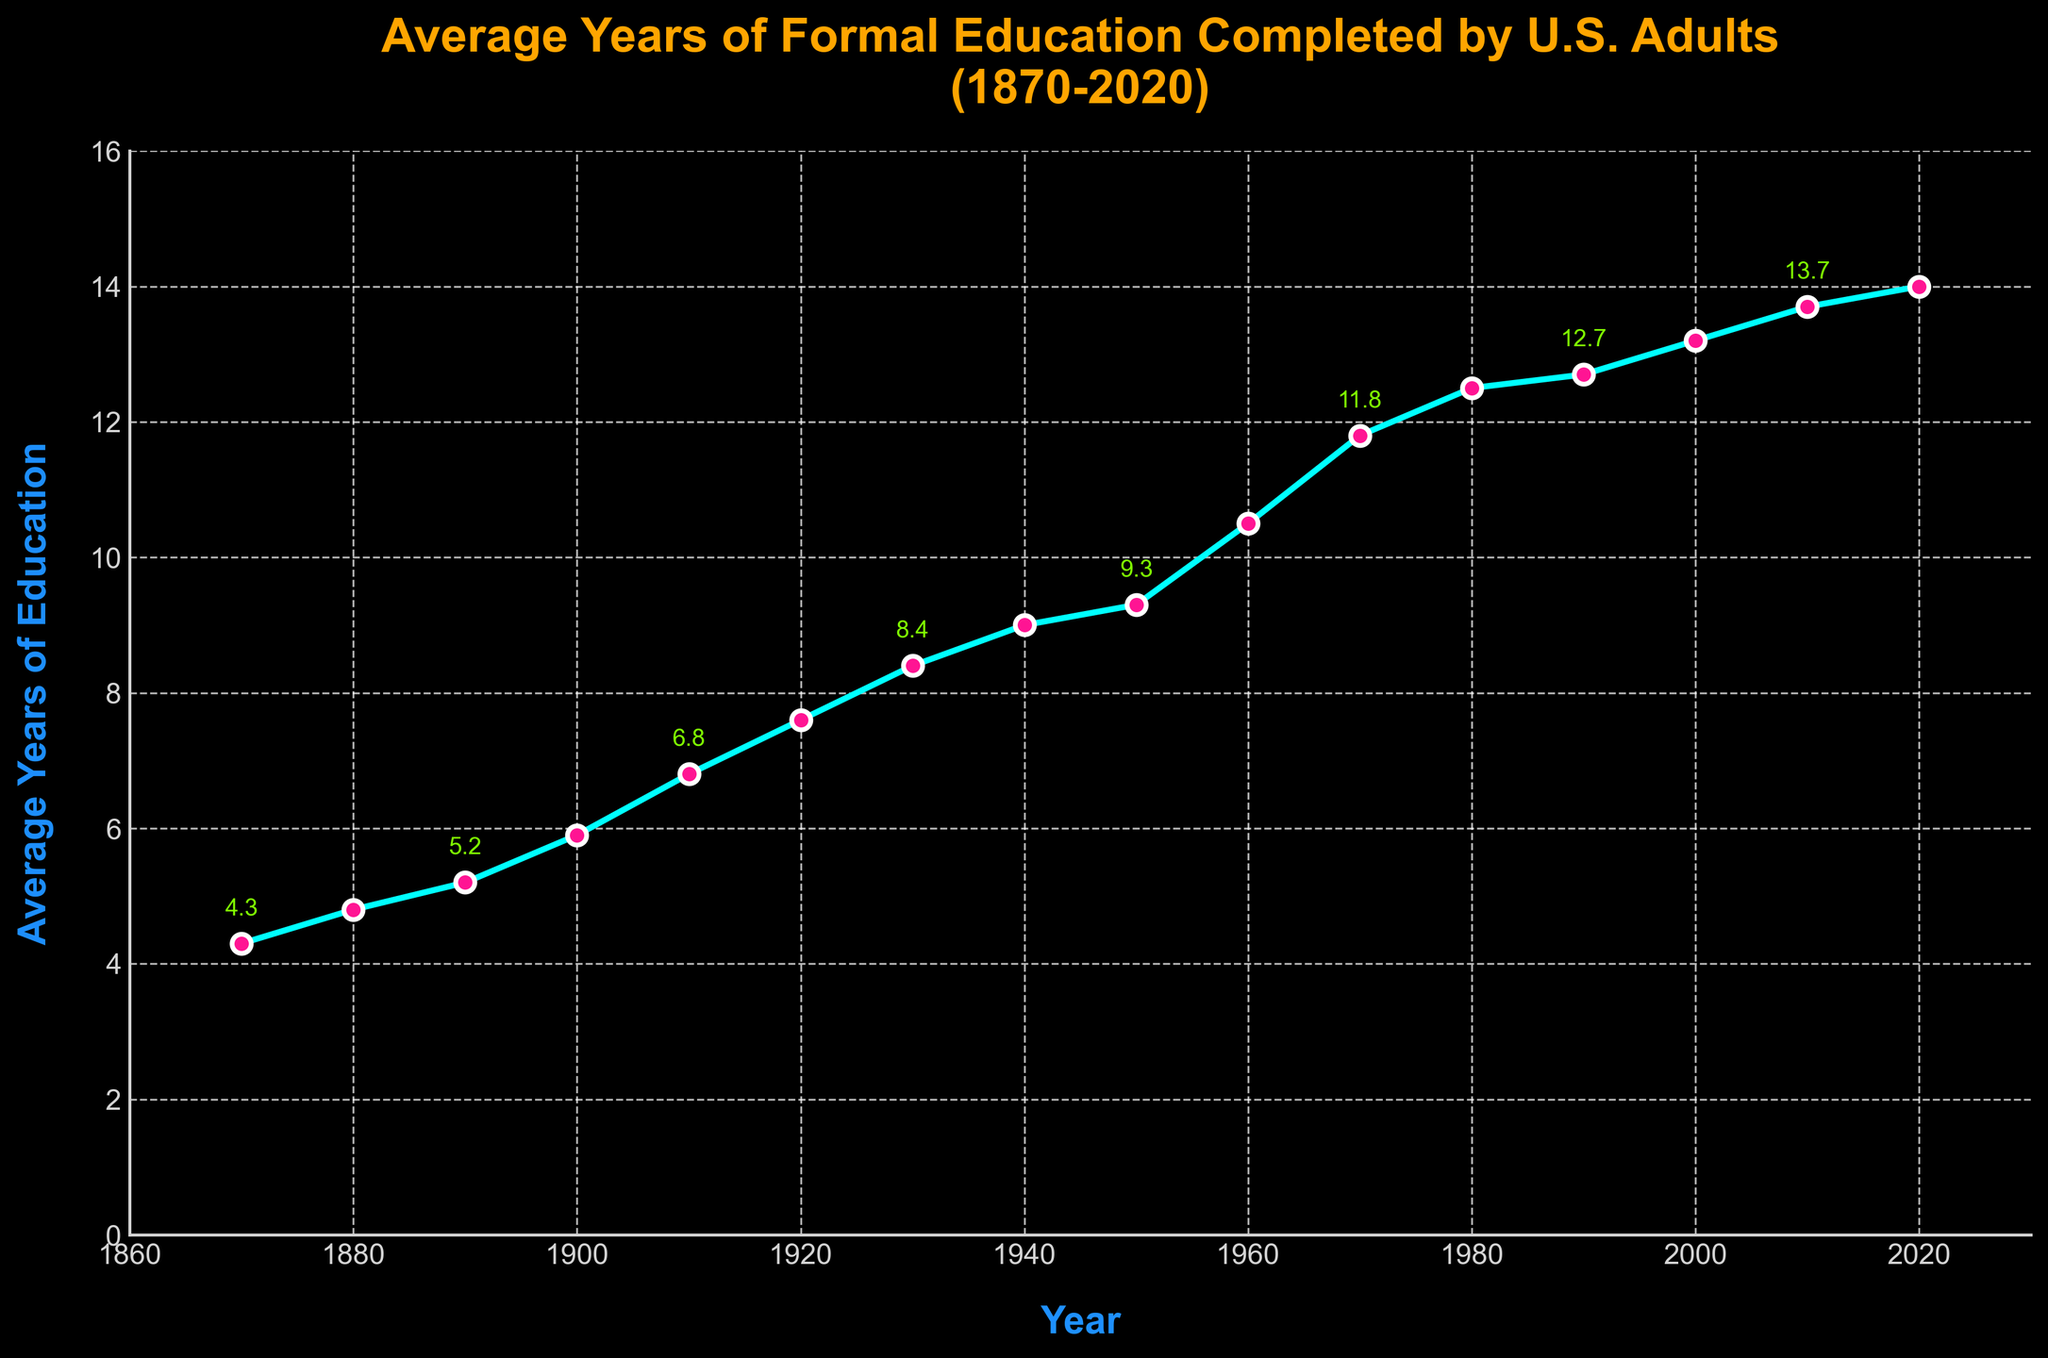Which year had the highest average years of education? To find the answer, look at the end of the line chart which shows the most recent data point. The year is 2020 and the average years of education is 14.0.
Answer: 2020 Between which two decades did the average years of education increase the most? Observe the line chart and look for the steepest slope between two decades. The increase from 1960 (10.5 years) to 1970 (11.8 years) is the steepest, giving an increase of 1.3 years.
Answer: 1960-1970 What is the average increase in years of education per decade from 1870 to 2020? Compute the total increase in years from 1870 (4.3 years) to 2020 (14.0 years), which is 9.7 years, then divide by the number of decades (15). 9.7 years / 15 decades = 0.6467 years per decade.
Answer: Approximately 0.65 years In which decade did the average years of education exceed 10 years for the first time? Look at the line chart and check the data points. It first exceeds 10 years in 1960, where the average is 10.5 years.
Answer: 1960 From 1940 to 1960, was the increase in average years of education greater than the increase from 1980 to 2000? Calculate the increases: 1940 (9.0) to 1960 (10.5) is 1.5 years; 1980 (12.5) to 2000 (13.2) is 0.7 years. Since 1.5 is greater than 0.7, the increase was greater from 1940 to 1960.
Answer: Yes How many years of education were added to the average from 1910 to 2020? Subtract the 1910 value (6.8 years) from the 2020 value (14.0 years). 14.0 - 6.8 = 7.2 years.
Answer: 7.2 years Did the average years of education always increase every decade? Examine the data points for each decade to check if each one is greater than the previous one. The data shows a consistent increase without any decreases.
Answer: Yes What's the rate of increase in average years of education between 2000 and 2010? Subtract the 2000 value (13.2) from the 2010 value (13.7), then divide by the number of years (10). (13.7 - 13.2) / 10 = 0.05 years per year.
Answer: 0.05 years per year During which decade did the average years of education increase from below 5 to above 5 years? Identify the decades around the 5-year mark: 1880 had 4.8 years, and 1890 had 5.2 years, so the transition occurred in this period.
Answer: 1880-1890 